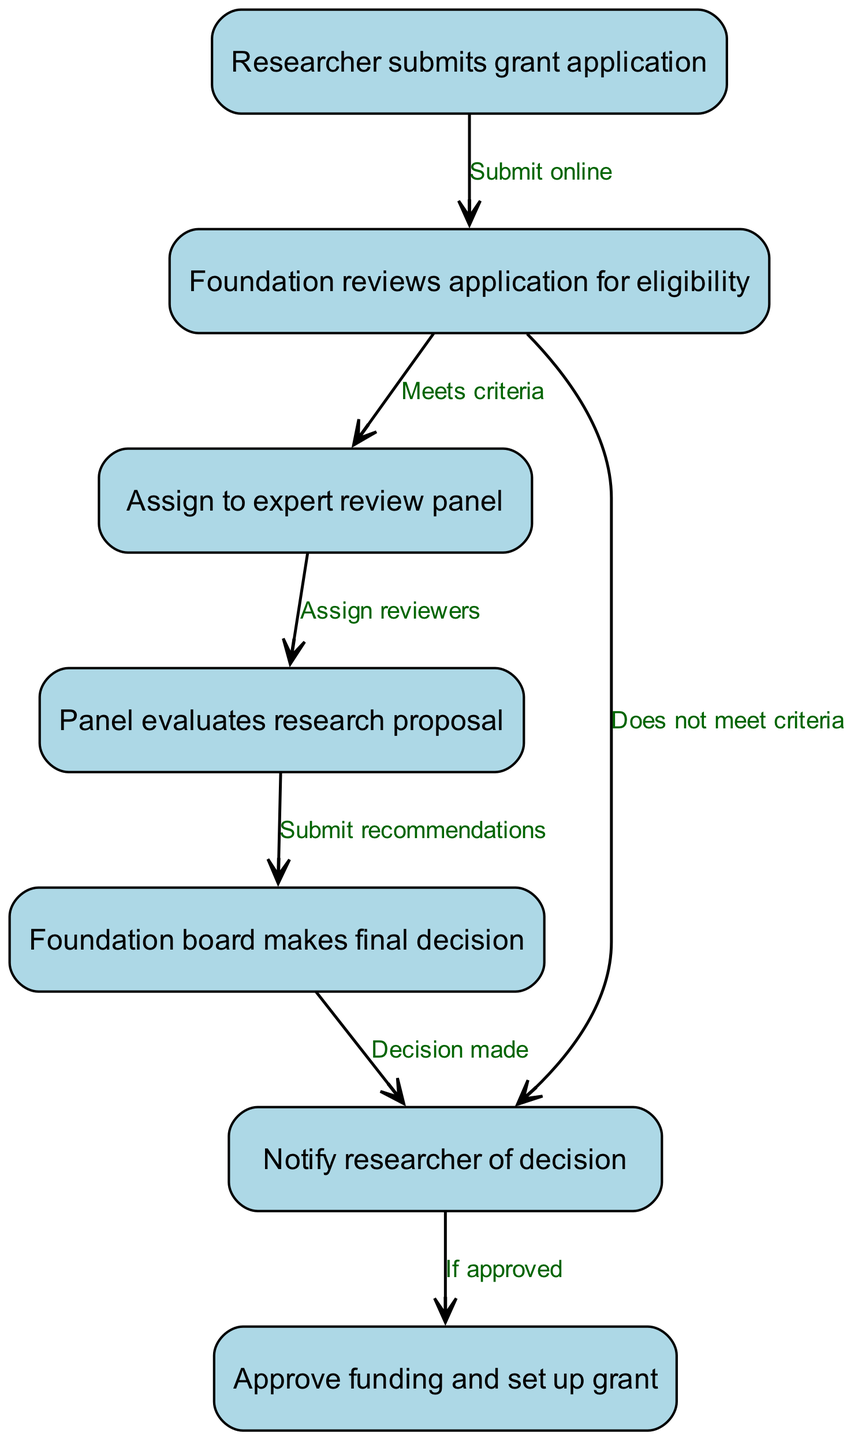What is the first step in the grant application process? The first step is indicated by the initial node in the flowchart, which states that the "Researcher submits grant application." This is the starting point of the entire process.
Answer: Researcher submits grant application How many nodes are in the flowchart? To determine the total number of nodes, I count each unique step represented in the diagram. According to the provided data, there are seven nodes listed.
Answer: 7 What does the foundation do after reviewing the application for eligibility? The flowchart indicates two potential paths after the foundation reviews the application. If the application meets criteria, it is assigned to an expert review panel. If it does not meet criteria, the researcher is notified of the decision.
Answer: Assign to expert review panel or Notify researcher of decision What happens after the panel evaluates the research proposal? The flowchart shows that after the panel evaluates the research proposal, the next step is for the panel to submit recommendations to the foundation board. This indicates a clear action that takes place following the evaluation.
Answer: Submit recommendations What decision does the foundation board make after submitting the evaluation? After the panel submits recommendations, the next action outlined in the flowchart is that the foundation board makes a final decision regarding the grant application. This establishes a direct outcome from the previous step.
Answer: Foundation board makes final decision What is required for the grant to be set up after the decision? According to the flowchart, for the grant to be set up, the decision must be approval from the board, indicated by the edge stating "If approved" leading to the action of approving funding and setting up the grant. Thus, the requirement is an approval.
Answer: Approval What action occurs if the application does not meet the eligibility criteria? The flowchart clearly indicates that if the application does not meet eligibility criteria, the flow proceeds to notify the researcher of the decision. This action shows the consequence of not meeting the criteria.
Answer: Notify researcher of decision What is the relationship between node 4 and node 5? The relationship between node 4 (Panel evaluates research proposal) and node 5 (Foundation board makes final decision) is established through the edge labeled "Submit recommendations." This indicates that node 5 follows node 4 as a result of the recommendations submitted.
Answer: Submit recommendations 